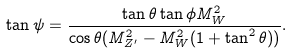<formula> <loc_0><loc_0><loc_500><loc_500>\tan \psi = \frac { \tan \theta \tan \phi M ^ { 2 } _ { W } } { \cos \theta ( M ^ { 2 } _ { Z ^ { \prime } } - M ^ { 2 } _ { W } ( 1 + \tan ^ { 2 } \theta ) ) } .</formula> 